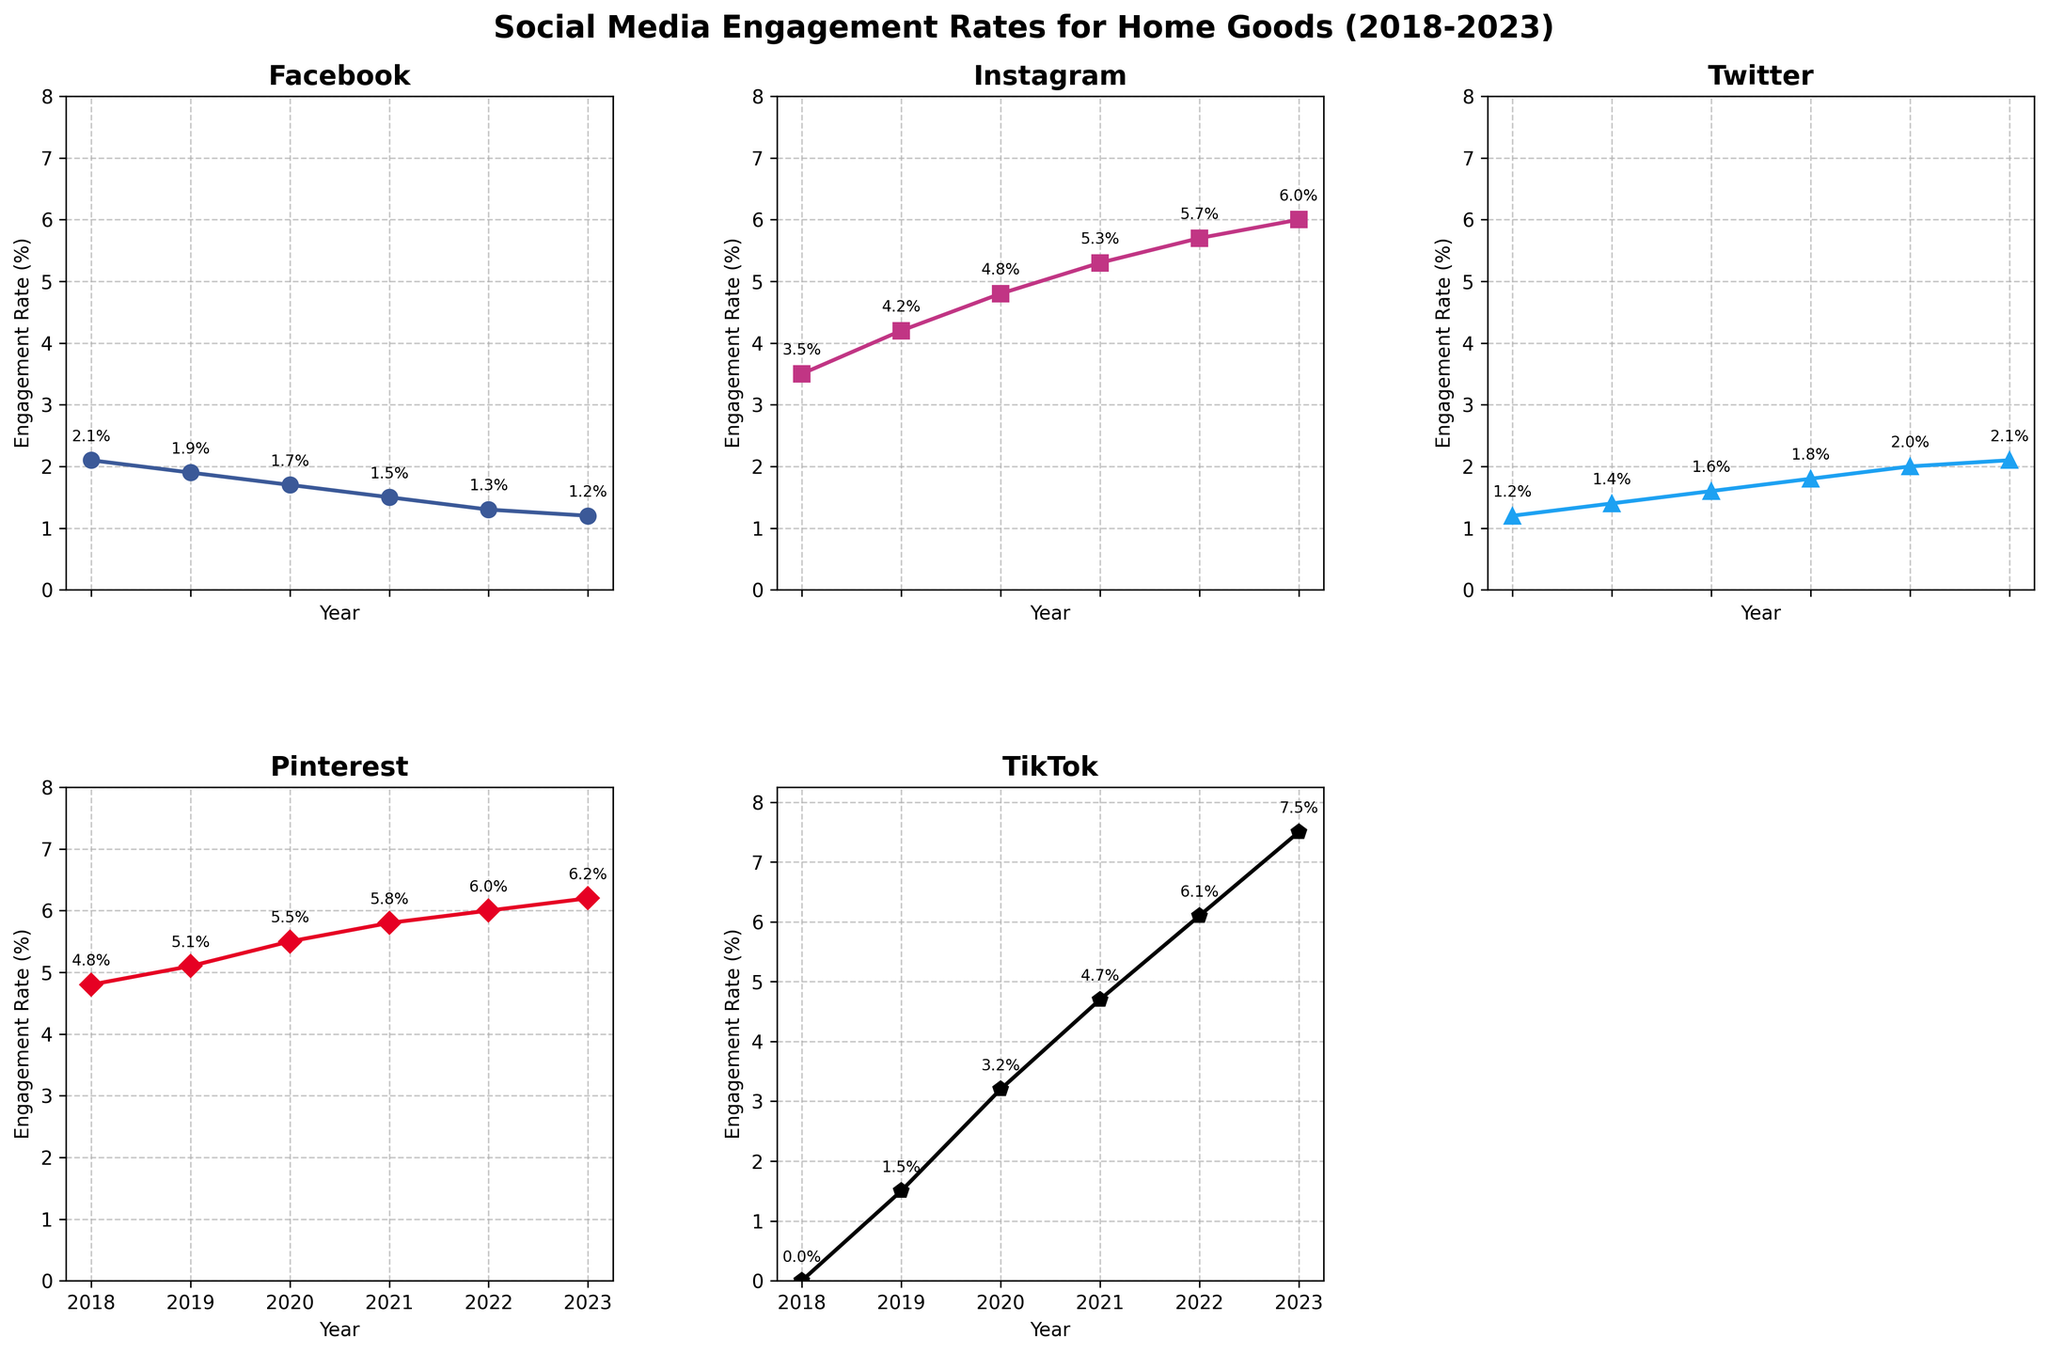Which social media platform saw the greatest increase in engagement rate from 2018 to 2023? By looking at the final and initial engagement rates in the plots for all platforms: Facebook (2.1% to 1.2%), Instagram (3.5% to 6.0%), Twitter (1.2% to 2.1%), Pinterest (4.8% to 6.2%), and TikTok (0% to 7.5%), we can see TikTok increased the most.
Answer: TikTok Which platform had the lowest engagement rate in 2023? By looking at the y-values of the data points for the year 2023, the lowest engagement rate among the platforms is seen in the Facebook subplot.
Answer: Facebook What was the engagement rate difference between Pinterest and Instagram in 2020? Looking at the 2020 data points from the plots: Pinterest (5.5%) and Instagram (4.8%), the difference is 5.5% - 4.8%.
Answer: 0.7% On which platform did the engagement rate remain consistently higher than 5% from 2020 to 2023? By observing the plots, Pinterest and Instagram both show engagement rates consistently higher than 5% from 2020 to 2023.
Answer: Pinterest and Instagram In which year did TikTok overtake Pinterest in terms of engagement rate? Examining the plots for TikTok and Pinterest, TikTok's engagement rate surpasses Pinterest's in 2022 (6.1% for TikTok vs 6.0% for Pinterest).
Answer: 2022 What is the trend for Facebook's engagement rate over the years? By looking at the plot for Facebook, the engagement rate shows a consistently decreasing trend from 2018 (2.1%) to 2023 (1.2%).
Answer: Decreasing Which platform had the highest engagement rate in 2018? Looking at the 2018 data points across all subplots, Pinterest had the highest engagement rate at 4.8%.
Answer: Pinterest How much did Instagram's engagement rate increase from 2019 to 2021? Observing the Instagram subplot, the engagement rate increased from 4.2% in 2019 to 5.3% in 2021, a difference of 1.1%.
Answer: 1.1% Which year's data for Twitter shows the highest engagement rate within the plotted years? By viewing the Twitter subplot, the highest engagement rate is seen in 2023 with a rate of 2.1%.
Answer: 2023 By what percentage did TikTok's engagement rate grow from 2020 to 2023? From the TikTok subplot, engagement increased from 3.2% in 2020 to 7.5% in 2023. The growth percentage is calculated as ((7.5 - 3.2) / 3.2) * 100.
Answer: 134.4% 